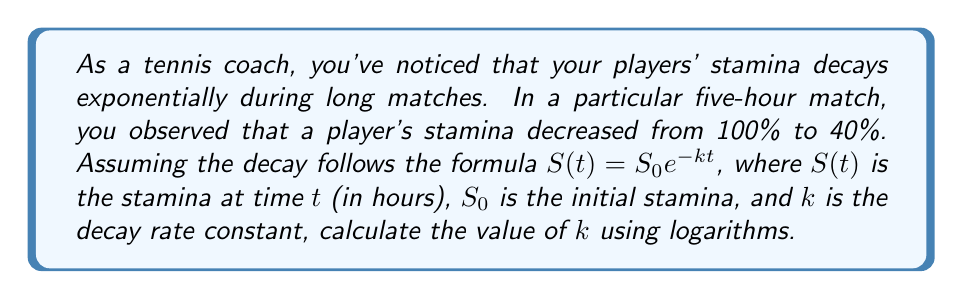Help me with this question. To solve this problem, we'll use the exponential decay formula and logarithms. Let's break it down step-by-step:

1) We're given the formula: $S(t) = S_0 e^{-kt}$

2) We know:
   - Initial stamina $S_0 = 100\%$
   - Final stamina $S(t) = 40\%$
   - Time $t = 5$ hours

3) Let's plug these values into the formula:
   $$40 = 100 e^{-5k}$$

4) Divide both sides by 100:
   $$0.4 = e^{-5k}$$

5) Now, let's take the natural logarithm of both sides:
   $$\ln(0.4) = \ln(e^{-5k})$$

6) Using the logarithm property $\ln(e^x) = x$, we get:
   $$\ln(0.4) = -5k$$

7) Solve for $k$:
   $$k = -\frac{\ln(0.4)}{5}$$

8) Calculate the value:
   $$k = -\frac{\ln(0.4)}{5} \approx 0.1833$$

Thus, the decay rate constant $k$ is approximately 0.1833 per hour.
Answer: $k \approx 0.1833$ per hour 